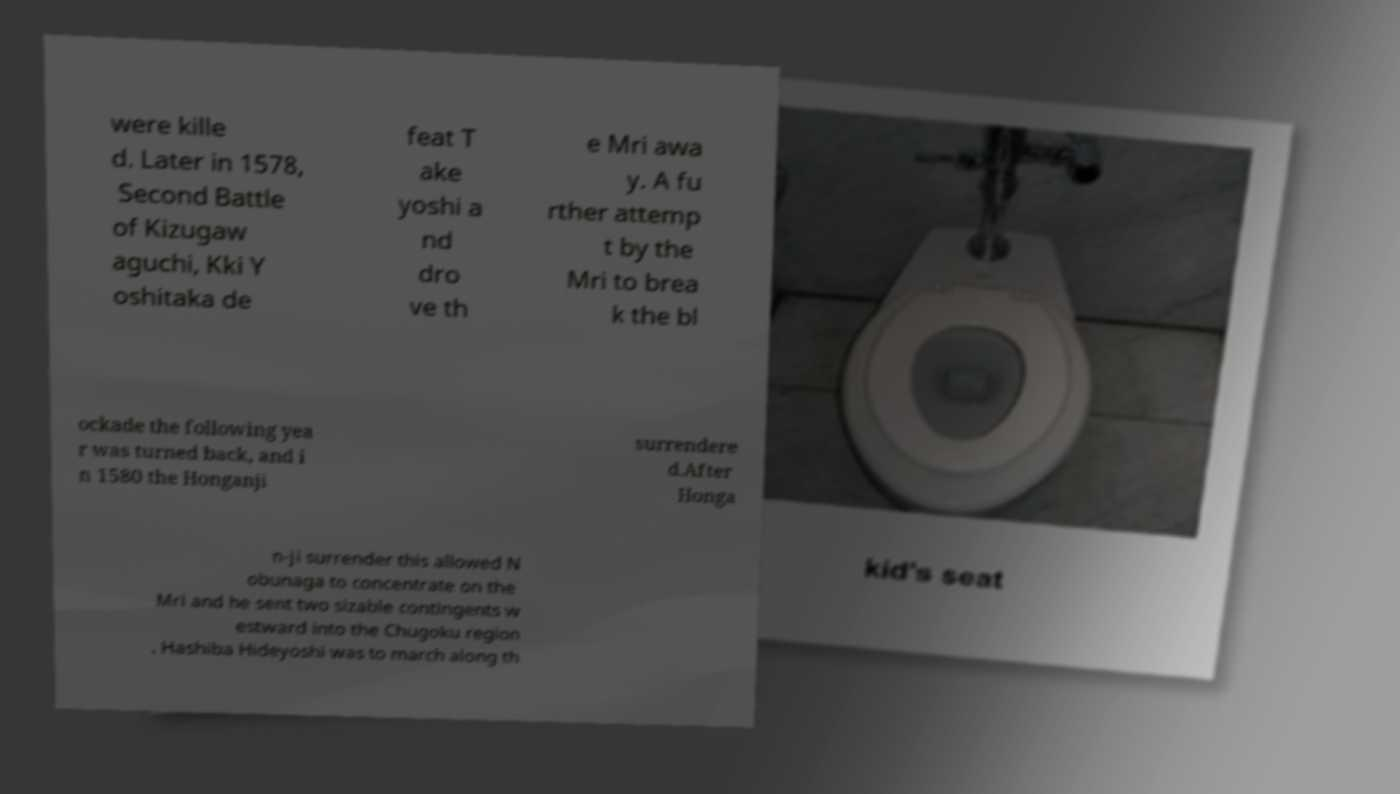For documentation purposes, I need the text within this image transcribed. Could you provide that? were kille d. Later in 1578, Second Battle of Kizugaw aguchi, Kki Y oshitaka de feat T ake yoshi a nd dro ve th e Mri awa y. A fu rther attemp t by the Mri to brea k the bl ockade the following yea r was turned back, and i n 1580 the Honganji surrendere d.After Honga n-ji surrender this allowed N obunaga to concentrate on the Mri and he sent two sizable contingents w estward into the Chugoku region . Hashiba Hideyoshi was to march along th 